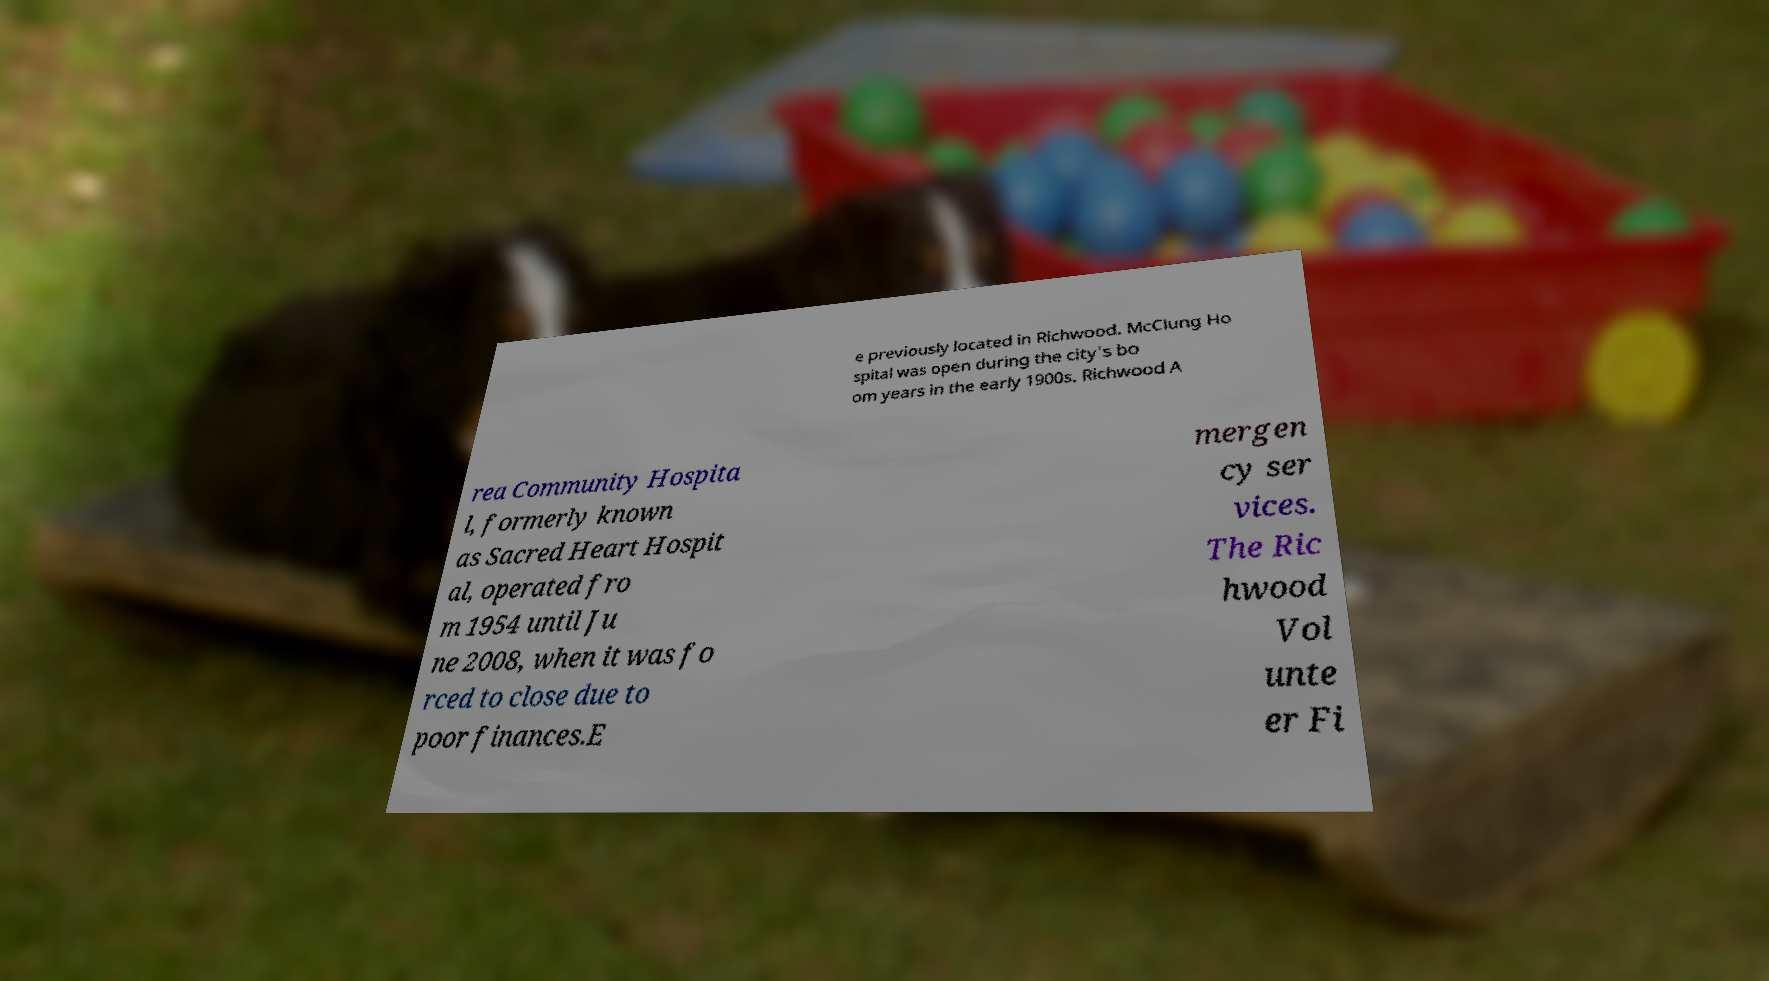Please read and relay the text visible in this image. What does it say? e previously located in Richwood. McClung Ho spital was open during the city's bo om years in the early 1900s. Richwood A rea Community Hospita l, formerly known as Sacred Heart Hospit al, operated fro m 1954 until Ju ne 2008, when it was fo rced to close due to poor finances.E mergen cy ser vices. The Ric hwood Vol unte er Fi 